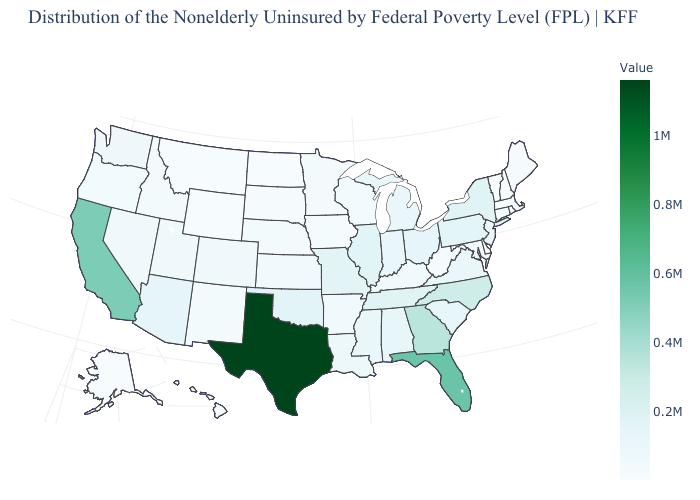Which states have the lowest value in the South?
Be succinct. Delaware. Among the states that border Alabama , does Florida have the highest value?
Answer briefly. Yes. Does Minnesota have the highest value in the MidWest?
Quick response, please. No. Does Utah have the highest value in the USA?
Quick response, please. No. Among the states that border Rhode Island , which have the highest value?
Short answer required. Massachusetts. Does New Mexico have a lower value than Tennessee?
Answer briefly. Yes. 